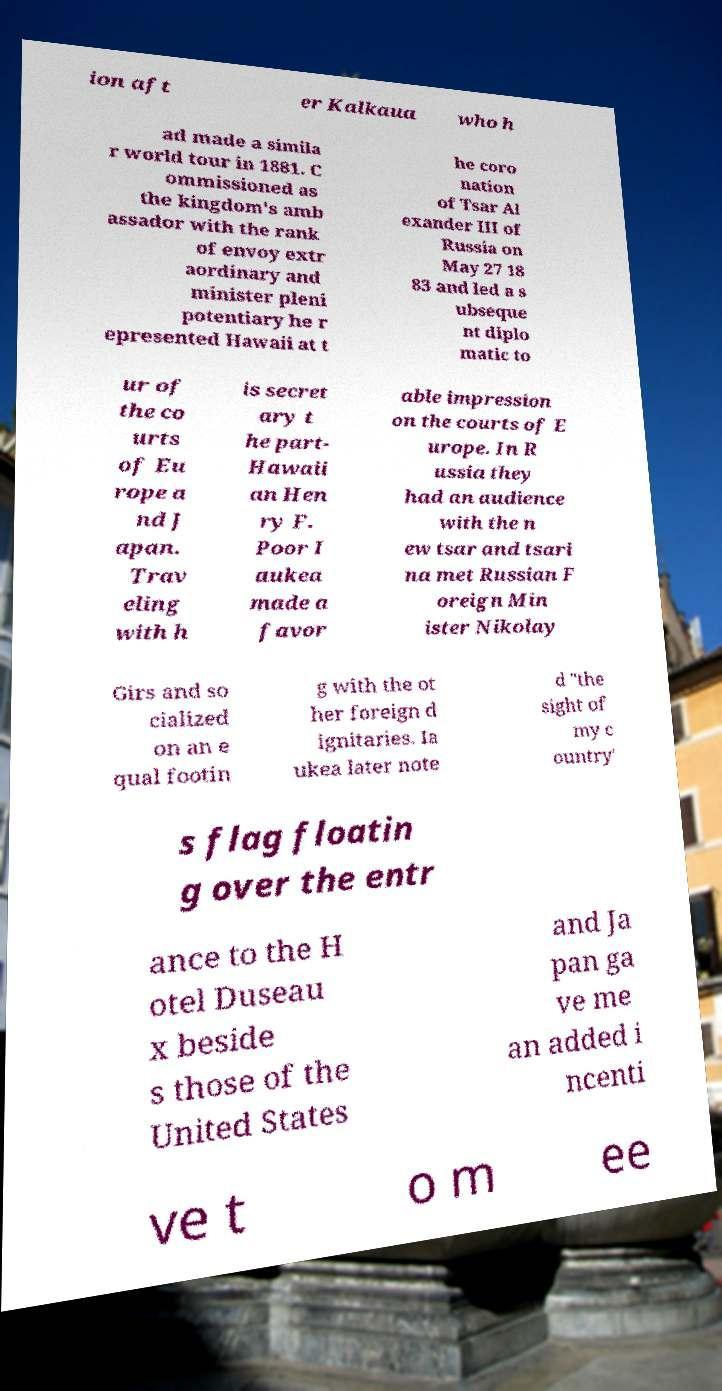For documentation purposes, I need the text within this image transcribed. Could you provide that? ion aft er Kalkaua who h ad made a simila r world tour in 1881. C ommissioned as the kingdom's amb assador with the rank of envoy extr aordinary and minister pleni potentiary he r epresented Hawaii at t he coro nation of Tsar Al exander III of Russia on May 27 18 83 and led a s ubseque nt diplo matic to ur of the co urts of Eu rope a nd J apan. Trav eling with h is secret ary t he part- Hawaii an Hen ry F. Poor I aukea made a favor able impression on the courts of E urope. In R ussia they had an audience with the n ew tsar and tsari na met Russian F oreign Min ister Nikolay Girs and so cialized on an e qual footin g with the ot her foreign d ignitaries. Ia ukea later note d "the sight of my c ountry' s flag floatin g over the entr ance to the H otel Duseau x beside s those of the United States and Ja pan ga ve me an added i ncenti ve t o m ee 